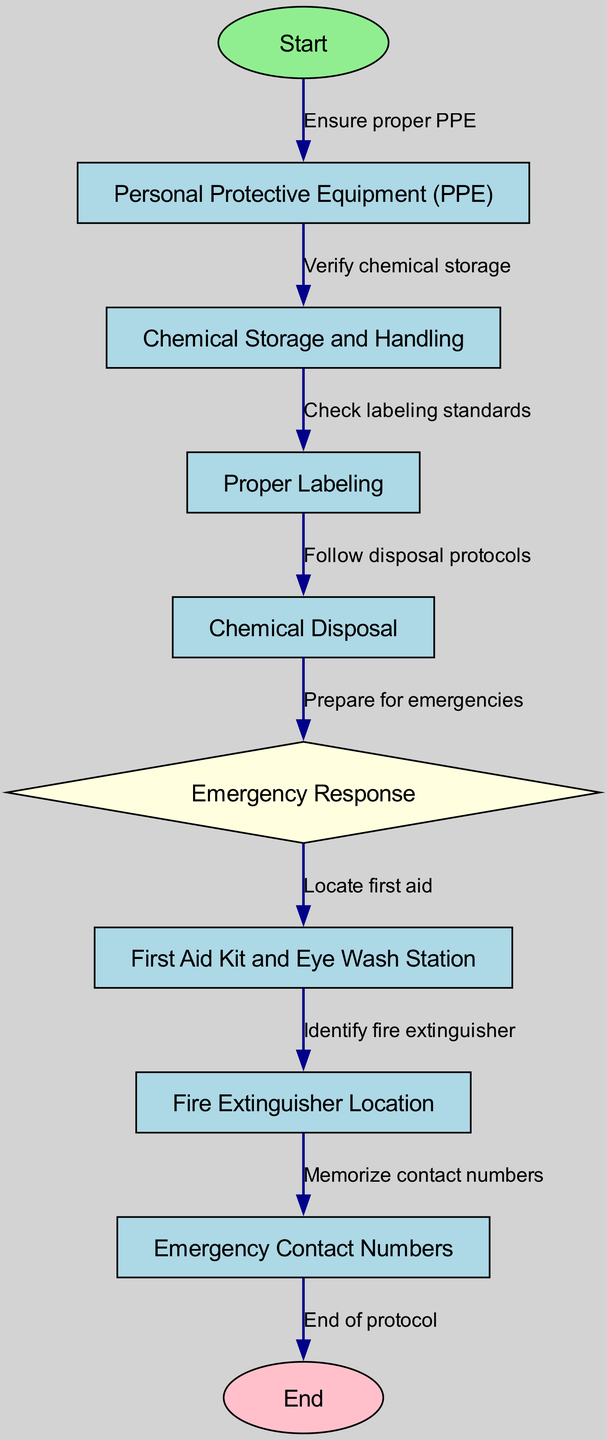What is the first step in the protocol? The first step begins with the node labeled "Start." From there, the flowchart indicates the first action is to ensure proper PPE is used.
Answer: Personal Protective Equipment (PPE) How many nodes are there in total? The diagram shows a list of nodes. Counting all the distinct nodes listed, from "Start" to "End," we find there are 10 nodes.
Answer: 10 What action comes after verifying chemical storage? According to the flowchart, after verifying chemical storage, the next action is to check labeling standards for those chemicals.
Answer: Check labeling standards Which node represents the emergency response section? The flowchart designates node number 6 to represent emergency response, visually indicated by a diamond shape.
Answer: Emergency Response What should be memorized at the end of the emergency response section? The flow from the emergency response node leads to the identification of emergency contact numbers, which should be memorized for safety.
Answer: Emergency Contact Numbers What is the shape of the node that deals with the first aid kit? In the diagram, the node dealing with the first aid kit is designed as a rectangle, distinct from the diamond shape of emergency response.
Answer: Rectangle What is the last step in the safety protocols? Following the flowchart, the last step indicated is the conclusion or end of the protocol, which is labeled as "End."
Answer: End of protocol What is the color used for the "Start" node? The "Start" node is clearly marked with a specified color, which is light green, distinguishing it from other nodes in the diagram.
Answer: Light Green What follows after chemical disposal? The flowchart indicates that following the chemical disposal, the focus shifts to preparing for emergencies in the lab.
Answer: Prepare for emergencies 